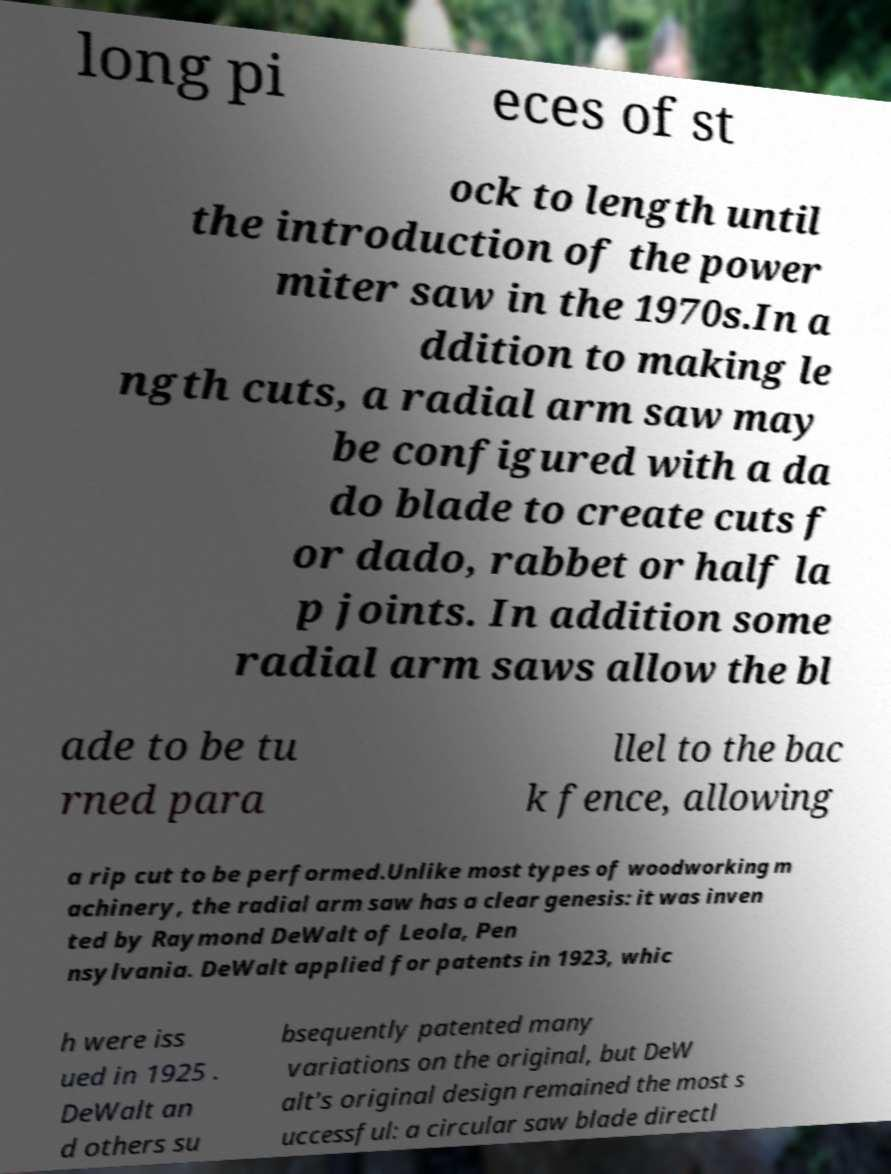Can you accurately transcribe the text from the provided image for me? long pi eces of st ock to length until the introduction of the power miter saw in the 1970s.In a ddition to making le ngth cuts, a radial arm saw may be configured with a da do blade to create cuts f or dado, rabbet or half la p joints. In addition some radial arm saws allow the bl ade to be tu rned para llel to the bac k fence, allowing a rip cut to be performed.Unlike most types of woodworking m achinery, the radial arm saw has a clear genesis: it was inven ted by Raymond DeWalt of Leola, Pen nsylvania. DeWalt applied for patents in 1923, whic h were iss ued in 1925 . DeWalt an d others su bsequently patented many variations on the original, but DeW alt's original design remained the most s uccessful: a circular saw blade directl 